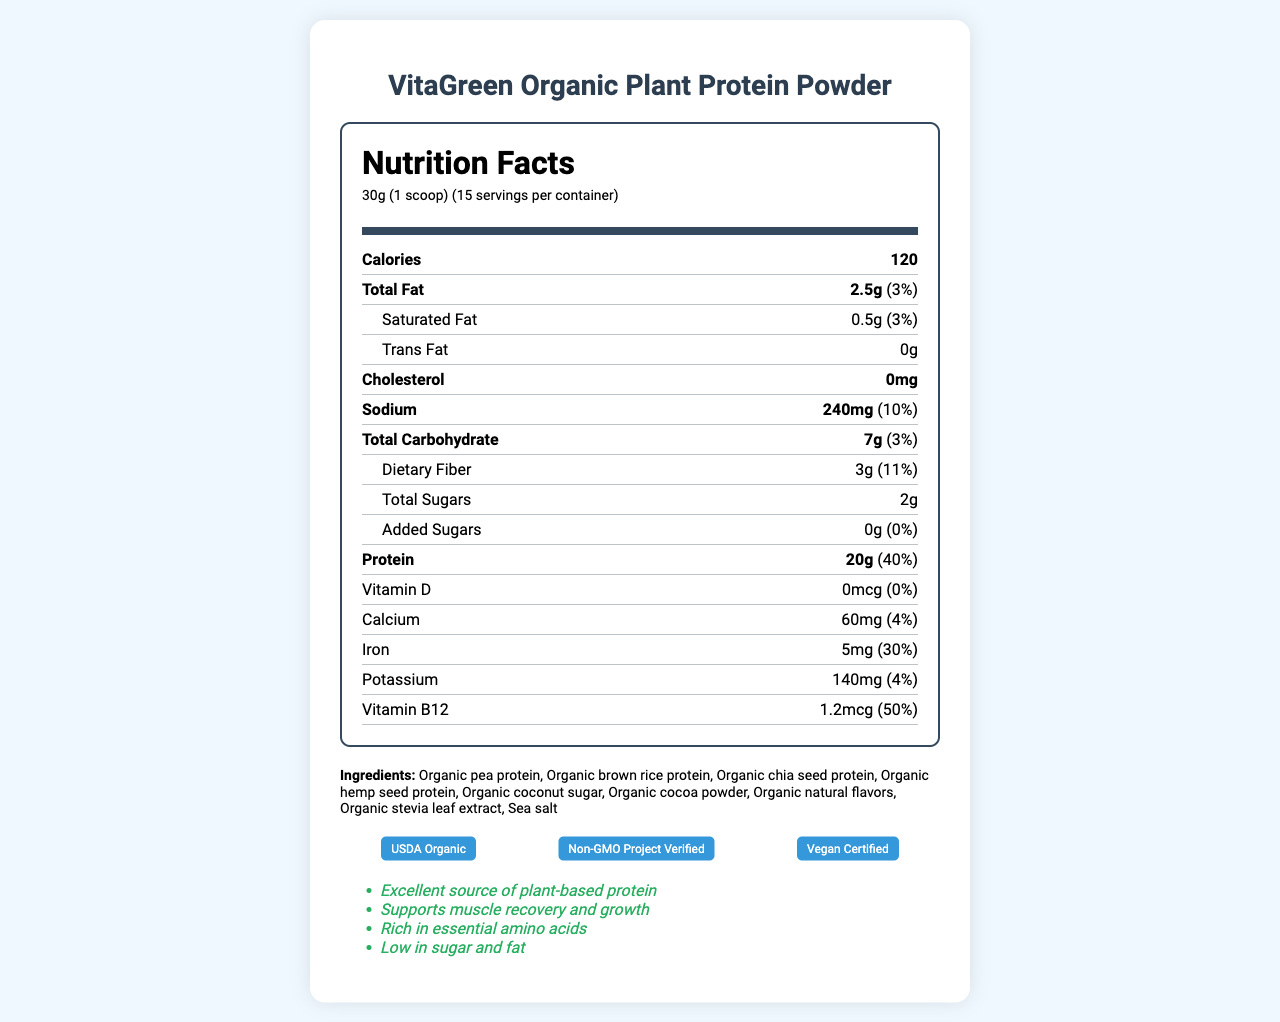what is the serving size? The serving size is specified as 30g which is equivalent to 1 scoop.
Answer: 30g (1 scoop) how many calories are in each serving? The nutrition facts label states that there are 120 calories per serving.
Answer: 120 how much protein is in one serving? The document specifies that one serving contains 20g of protein.
Answer: 20g name three key ingredients The document lists multiple ingredients, three of which include Organic pea protein, Organic brown rice protein, and Organic chia seed protein.
Answer: Organic pea protein, Organic brown rice protein, Organic chia seed protein what is the daily value percentage of vitamin B12? The nutrition facts indicate that the daily value percentage of vitamin B12 is 50%.
Answer: 50% in what type of facility is the protein powder manufactured? The allergen information specifies that the product is manufactured in a facility that also processes tree nuts, soy, and dairy.
Answer: A facility that also processes tree nuts, soy, and dairy which of the following nutrients has the highest daily value percentage? A. Calcium B. Protein C. Iron D. Sodium The daily value percentages are: Calcium - 4%, Protein - 40%, Iron - 30%, Sodium - 10%. Protein has the highest daily value percentage.
Answer: B. Protein which certification does the product have? A. Vegan Certified B. Gluten-Free Certified C. USDA Organic D. Non-GMO Project Verified The product has the following certifications: USDA Organic, Non-GMO Project Verified, Vegan Certified.
Answer: A, C, D does the product contain any added sugars? The document specifies that the product contains 0g of added sugars.
Answer: No is this protein powder suitable for vegans? The certifications include Vegan Certified, indicating that the protein powder is suitable for vegans.
Answer: Yes summarize the main features of the VitaGreen Organic Plant Protein Powder This protein powder is a high-protein, plant-based option with various health certifications and claims. It contains no added sugars and is low in fat while providing significant amounts of iron and vitamin B12.
Answer: The VitaGreen Organic Plant Protein Powder provides a plant-based protein option with a detailed macronutrient breakdown. Each 30g serving contains 120 calories, 20g of protein, and is low in fat and sugars. The product is USDA Organic, Non-GMO Project Verified, and Vegan Certified. It contains a blend of organic pea, brown rice, chia seed, and hemp seed proteins. The protein powder also supports muscle recovery and growth, and is manufactured in a facility that processes tree nuts, soy, and dairy. The product comes with storage and usage instructions. what are the sources of protein in the powder and their respective percentages? The additional information section of the document breaks down the percentage of each protein source.
Answer: Pea protein (40%), Brown rice protein (30%), Chia seed protein (15%), Hemp seed protein (15%) how much dietary fiber is in one serving? The nutritional facts section lists 3g of dietary fiber per serving.
Answer: 3g how should the protein powder be stored? The storage instructions suggest storing the powder in a cool and dry place and sealing it tightly after opening.
Answer: Store in a cool, dry place. Seal tightly after opening. what is the purpose of the product according to the health claims? One of the health claims indicates that the product supports muscle recovery and growth.
Answer: Supports muscle recovery and growth does the document provide the price of the protein powder? The document does not provide any pricing information.
Answer: Not enough information 